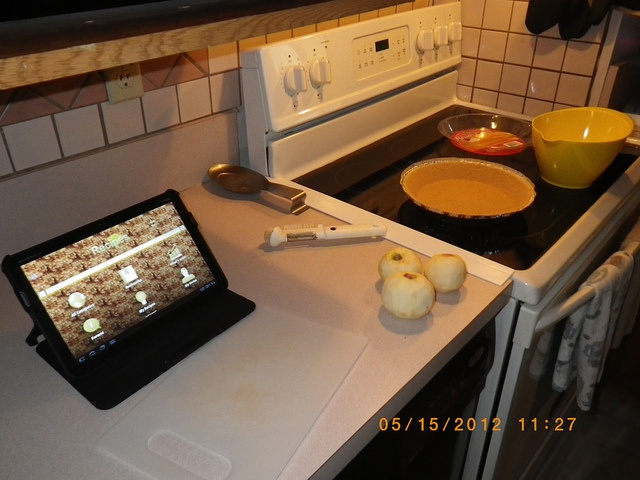Describe the objects in this image and their specific colors. I can see oven in black, tan, gray, and red tones, laptop in black, tan, gray, and maroon tones, bowl in black, red, orange, and maroon tones, bowl in black, maroon, red, and brown tones, and spoon in black, maroon, and brown tones in this image. 